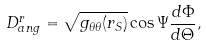Convert formula to latex. <formula><loc_0><loc_0><loc_500><loc_500>D ^ { r } _ { a n g } = \sqrt { g _ { \theta \theta } ( r _ { S } ) } \cos \Psi \frac { d \Phi } { d \Theta } ,</formula> 